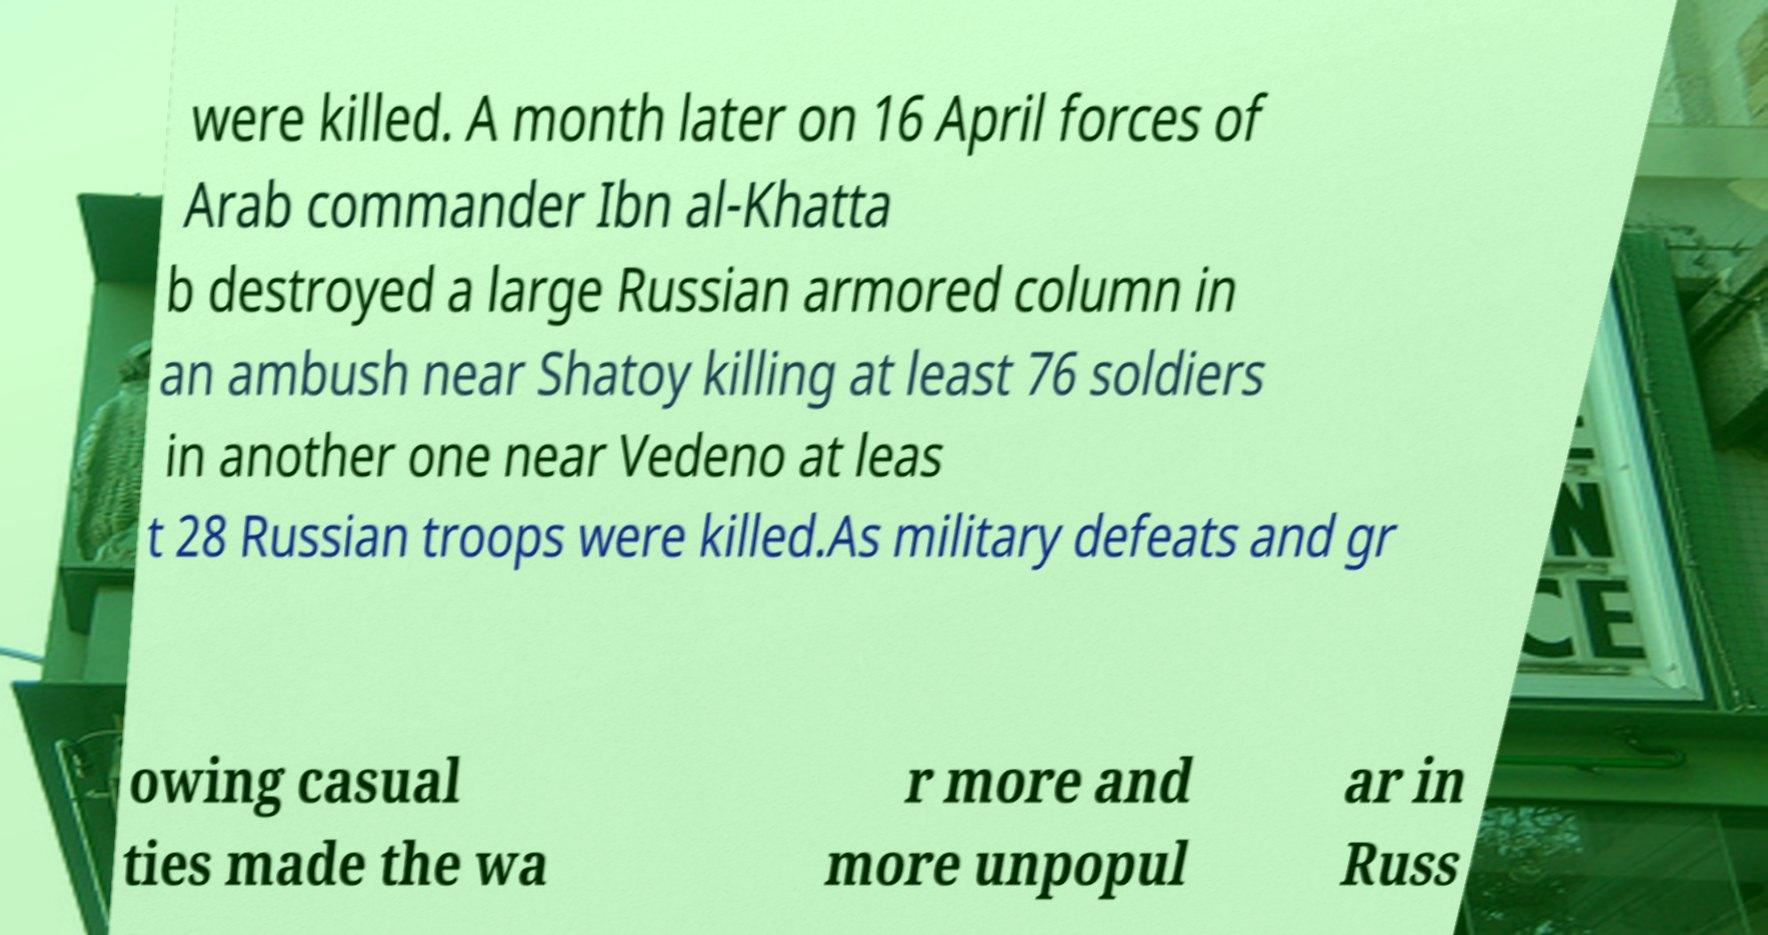Can you read and provide the text displayed in the image?This photo seems to have some interesting text. Can you extract and type it out for me? were killed. A month later on 16 April forces of Arab commander Ibn al-Khatta b destroyed a large Russian armored column in an ambush near Shatoy killing at least 76 soldiers in another one near Vedeno at leas t 28 Russian troops were killed.As military defeats and gr owing casual ties made the wa r more and more unpopul ar in Russ 